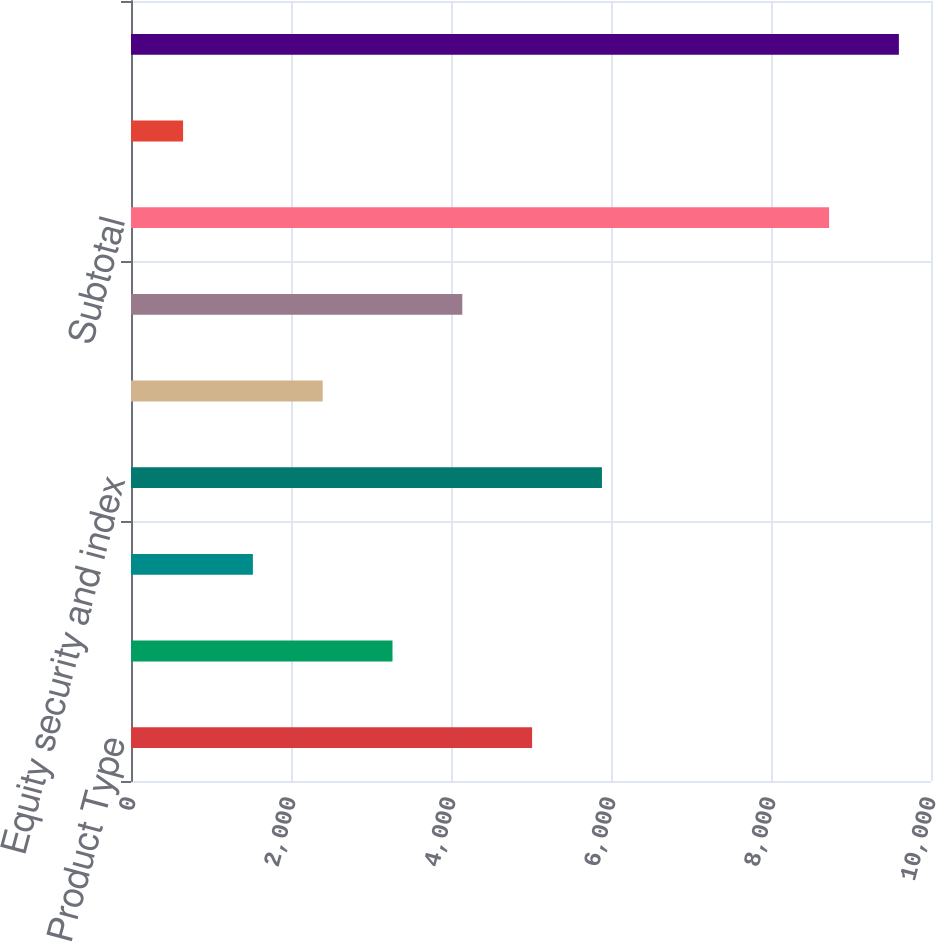Convert chart to OTSL. <chart><loc_0><loc_0><loc_500><loc_500><bar_chart><fcel>Product Type<fcel>Interest rate contracts<fcel>Foreign exchange contracts<fcel>Equity security and index<fcel>Commodity and other<fcel>Credit contracts<fcel>Subtotal<fcel>Debt valuation adjustment<fcel>Total<nl><fcel>5014<fcel>3268.8<fcel>1523.6<fcel>5886.6<fcel>2396.2<fcel>4141.4<fcel>8726<fcel>651<fcel>9598.6<nl></chart> 